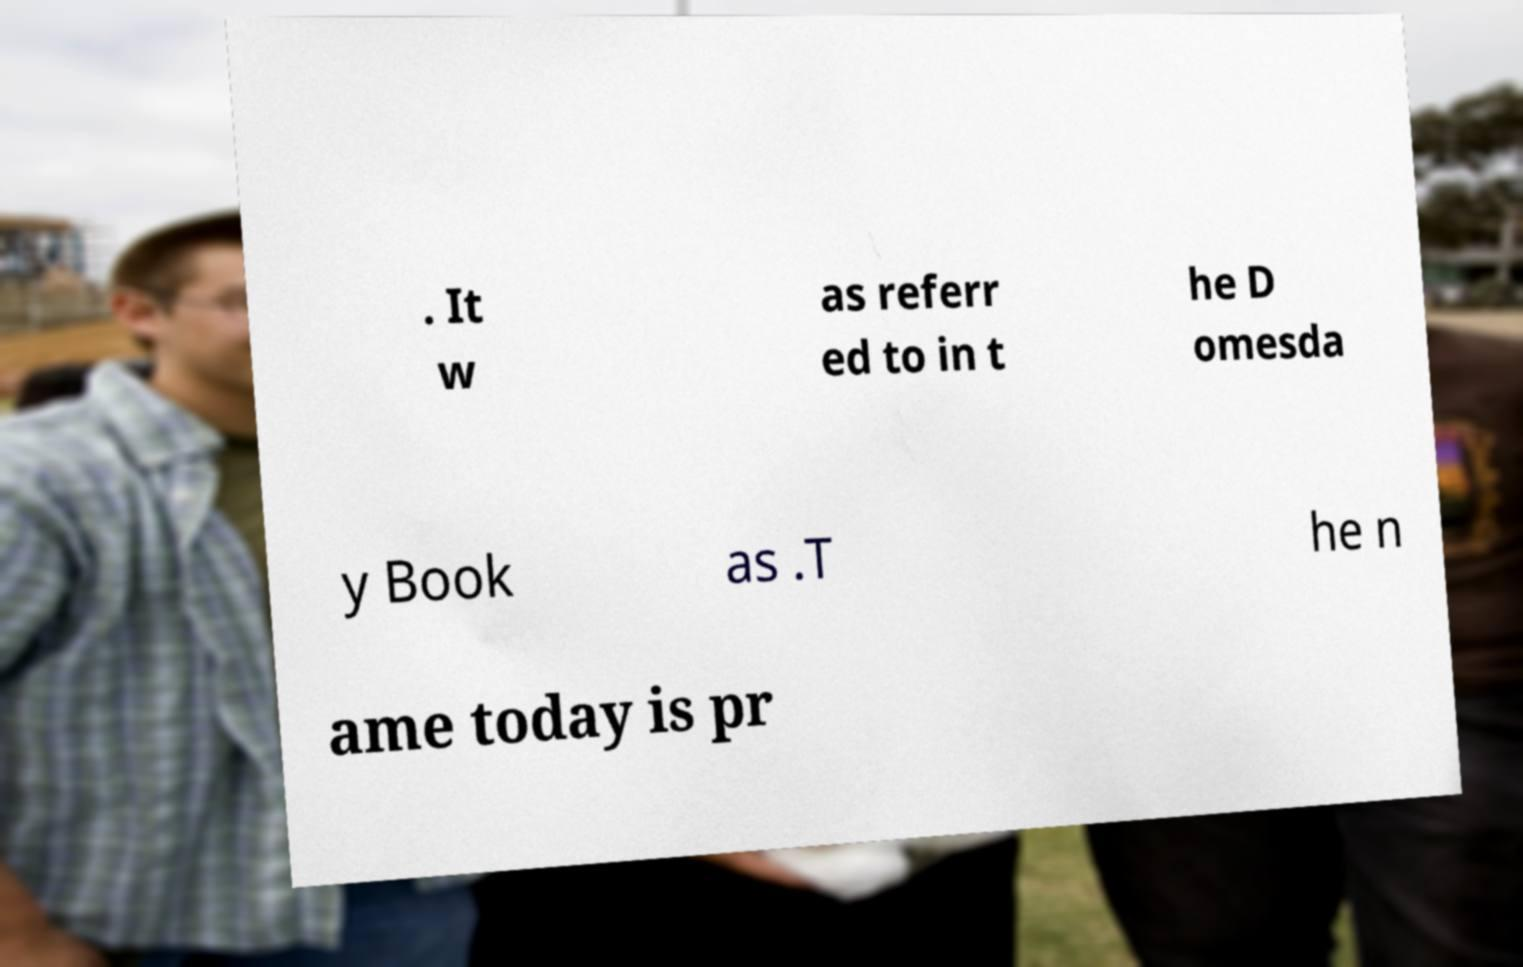There's text embedded in this image that I need extracted. Can you transcribe it verbatim? . It w as referr ed to in t he D omesda y Book as .T he n ame today is pr 